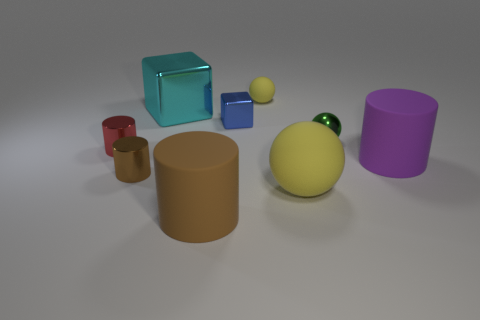Subtract all tiny red metallic cylinders. How many cylinders are left? 3 Subtract all yellow spheres. How many spheres are left? 1 Subtract all cylinders. How many objects are left? 5 Subtract 2 cubes. How many cubes are left? 0 Add 8 tiny spheres. How many tiny spheres are left? 10 Add 1 small objects. How many small objects exist? 6 Subtract 0 purple blocks. How many objects are left? 9 Subtract all blue cylinders. Subtract all gray cubes. How many cylinders are left? 4 Subtract all purple cylinders. How many red balls are left? 0 Subtract all big yellow spheres. Subtract all purple things. How many objects are left? 7 